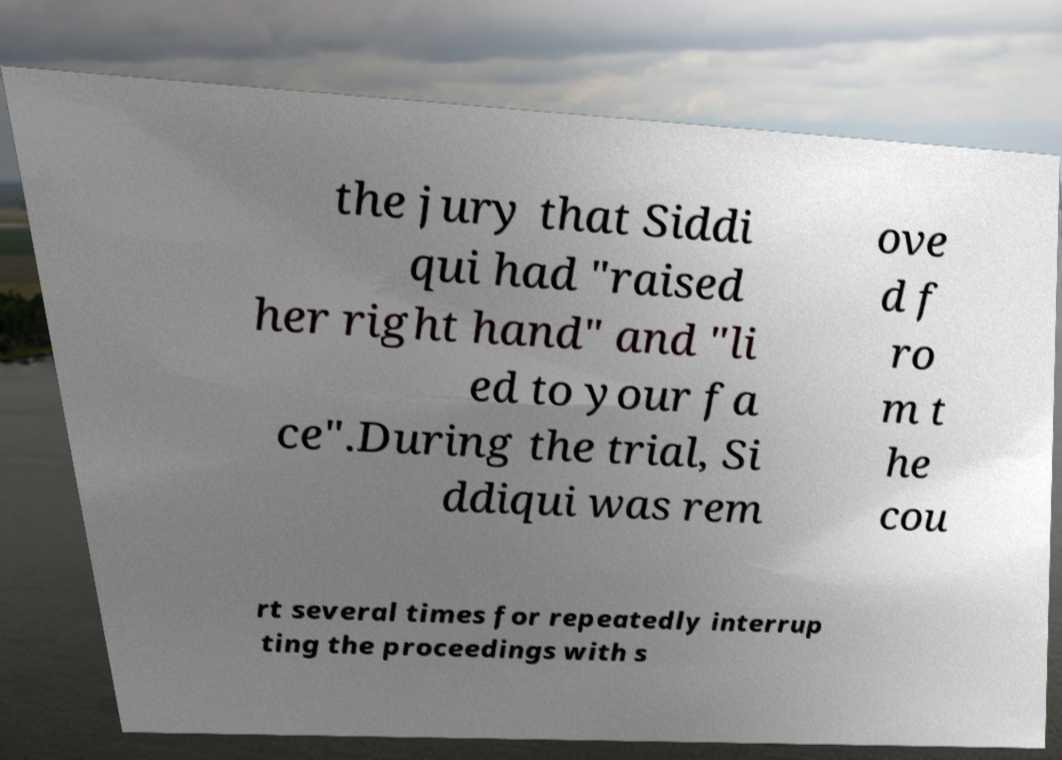What messages or text are displayed in this image? I need them in a readable, typed format. the jury that Siddi qui had "raised her right hand" and "li ed to your fa ce".During the trial, Si ddiqui was rem ove d f ro m t he cou rt several times for repeatedly interrup ting the proceedings with s 